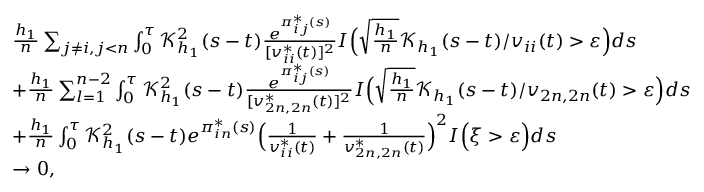<formula> <loc_0><loc_0><loc_500><loc_500>\begin{array} { r l } & { \frac { h _ { 1 } } { n } \sum _ { j \neq i , j < n } \int _ { 0 } ^ { \tau } \mathcal { K } _ { h _ { 1 } } ^ { 2 } ( s - t ) \frac { e ^ { \pi _ { i j } ^ { * } ( s ) } } { [ v _ { i i } ^ { * } ( t ) ] ^ { 2 } } I \left ( \sqrt { \frac { h _ { 1 } } { n } } \mathcal { K } _ { h _ { 1 } } ( s - t ) / v _ { i i } ( t ) > \varepsilon \right ) d s } \\ & { + \frac { h _ { 1 } } { n } \sum _ { l = 1 } ^ { n - 2 } \int _ { 0 } ^ { \tau } \mathcal { K } _ { h _ { 1 } } ^ { 2 } ( s - t ) \frac { e ^ { \pi _ { i j } ^ { * } ( s ) } } { [ v _ { 2 n , 2 n } ^ { * } ( t ) ] ^ { 2 } } I \left ( \sqrt { \frac { h _ { 1 } } { n } } \mathcal { K } _ { h _ { 1 } } ( s - t ) / v _ { 2 n , 2 n } ( t ) > \varepsilon \right ) d s } \\ & { + \frac { h _ { 1 } } { n } \int _ { 0 } ^ { \tau } \mathcal { K } _ { h _ { 1 } } ^ { 2 } ( s - t ) e ^ { \pi _ { i n } ^ { * } ( s ) } \left ( \frac { 1 } { v _ { i i } ^ { * } ( t ) } + \frac { 1 } { v _ { 2 n , 2 n } ^ { * } ( t ) } \right ) ^ { 2 } I \left ( \xi > \varepsilon \right ) d s } \\ & { \rightarrow 0 , } \end{array}</formula> 